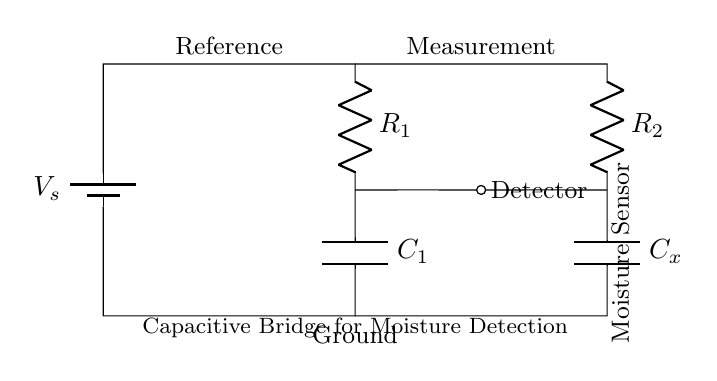What is the value of the reference resistor? The reference resistor is labeled as R1 in the circuit. By identifying the components, we can see that R1 is indeed the reference resistor.
Answer: R1 What component is labeled as the moisture sensor in the circuit? The component that is labeled as the moisture sensor is Cx, which is a capacitor in the circuit designed to detect moisture levels based on its capacitance change.
Answer: Cx What happens when moisture levels increase in the storage facility? When moisture levels increase, the capacitance of Cx increases, which can cause an imbalance in the bridge circuit, allowing for detection of the moisture.
Answer: Imbalance What is the purpose of the battery in this circuit? The battery provides the necessary voltage to power the circuit and enable the measurements of the capacitance changes in response to moisture levels.
Answer: Voltage What can be inferred about the relationships between R1, R2, C1, and Cx in this bridge configuration? In this capacitive bridge circuit, R1 and R2 are part of the balance condition, while C1 and Cx function similarly; changes in Cx, due to moisture, affect the bridge balance by altering its capacitance, leading to a measurable output.
Answer: Balance condition How does the detector interact with the capacitive bridge circuit? The detector measures the voltage difference across the outputs of the bridge created by changes in capacitance from Cx due to moisture presence, determining moisture levels indirectly.
Answer: Measures voltage difference 